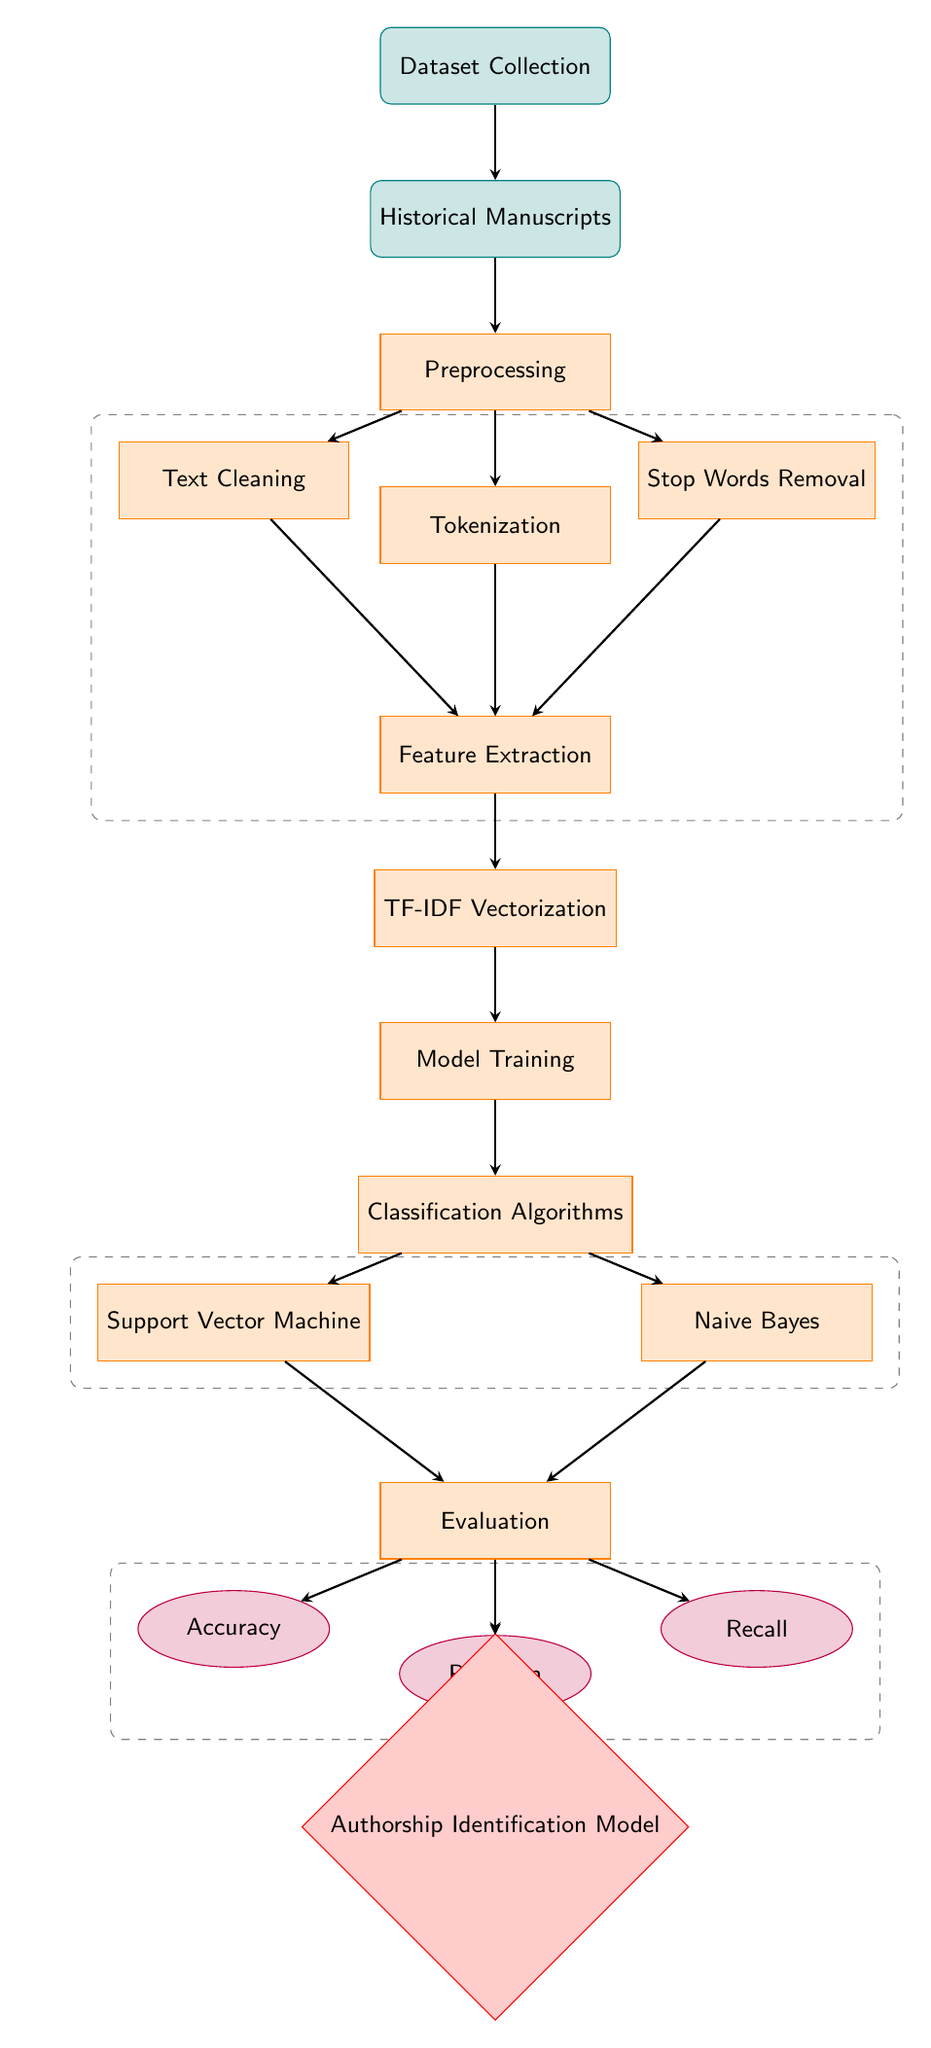What is the first step in the diagram? The first step in the diagram is "Dataset Collection," which is the topmost node. This indicates that the process begins with gathering relevant datasets.
Answer: Dataset Collection How many classification algorithms are shown in the diagram? The diagram displays two classification algorithms: "Support Vector Machine" and "Naive Bayes.” These are indicated as separate nodes under the Classification Algorithms process.
Answer: Two What follows after TF-IDF Vectorization in the process? "Model Training" follows directly after "TF-IDF Vectorization," which is shown as the next node in the flow of processes.
Answer: Model Training Which metric is located to the right of Evaluation? The metric located to the right of "Evaluation" is "Recall," as indicated by the position of the nodes in relation to each other.
Answer: Recall What is the overall outcome of the diagram? The overall outcome of the diagram is "Authorship Identification Model," which is the final result after evaluating the model.
Answer: Authorship Identification Model Explain the role of "Text Cleaning" in the preprocessing stage. "Text Cleaning" is a separate process that serves to prepare the text data before further processing. It focuses on removing noise and irrelevant information to enhance the dataset's quality for feature extraction.
Answer: Prepare the text data Which metric evaluates the proportion of actual positive cases correctly identified? The metric that evaluates the proportion of actual positive cases correctly identified is "Precision," as defined explicitly in the diagram's layout.
Answer: Precision What processes are grouped in the dashed box on the left side? The dashed box on the left side groups "Text Cleaning," "Stop Words Removal," and "Feature Extraction," indicating that these processes are part of a specific preprocessing workflow prior to TF-IDF Vectorization.
Answer: Text Cleaning, Stop Words Removal, and Feature Extraction What is the relationship between the "Training" and "Classification Algorithms"? "Training" is a process that leads directly to "Classification Algorithms," meaning that training is a prerequisite for selecting and implementing the algorithms.
Answer: Training leads to Classification Algorithms 